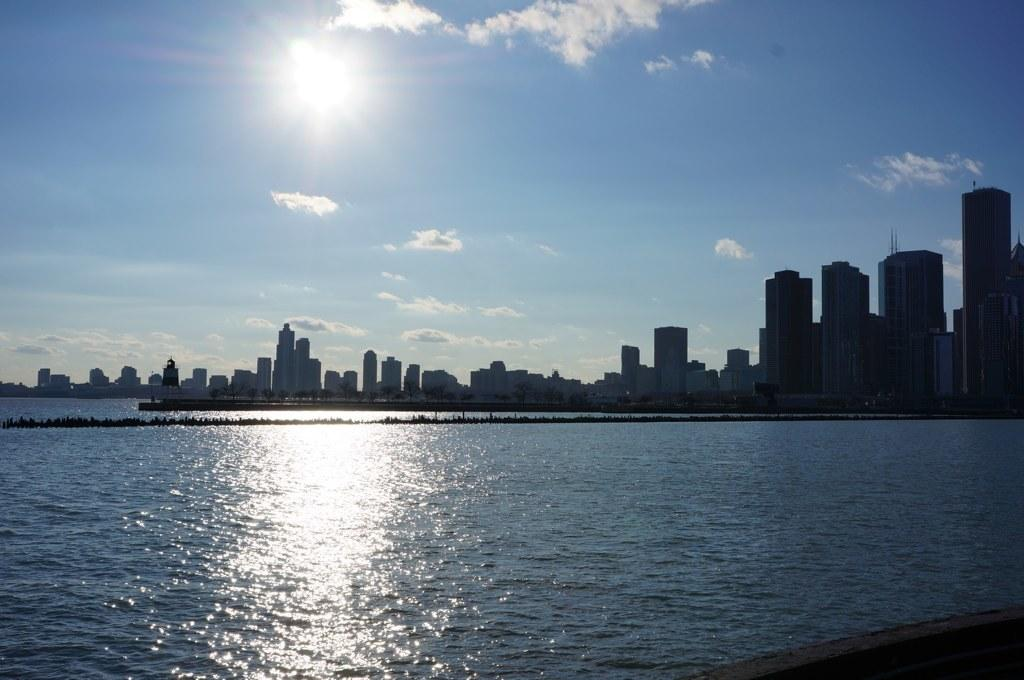What type of natural feature is present in the image? The image contains a sea. What type of structures are located near the sea? There are buildings adjacent to the sea. How would you describe the sky in the image? The sky is blue and cloudy. Can you see any celestial bodies in the sky? Yes, the sun is visible in the sky. What type of grass is growing in the front of the buildings in the image? There is no grass visible in the image; it features a sea, buildings, and a blue, cloudy sky with the sun visible. 